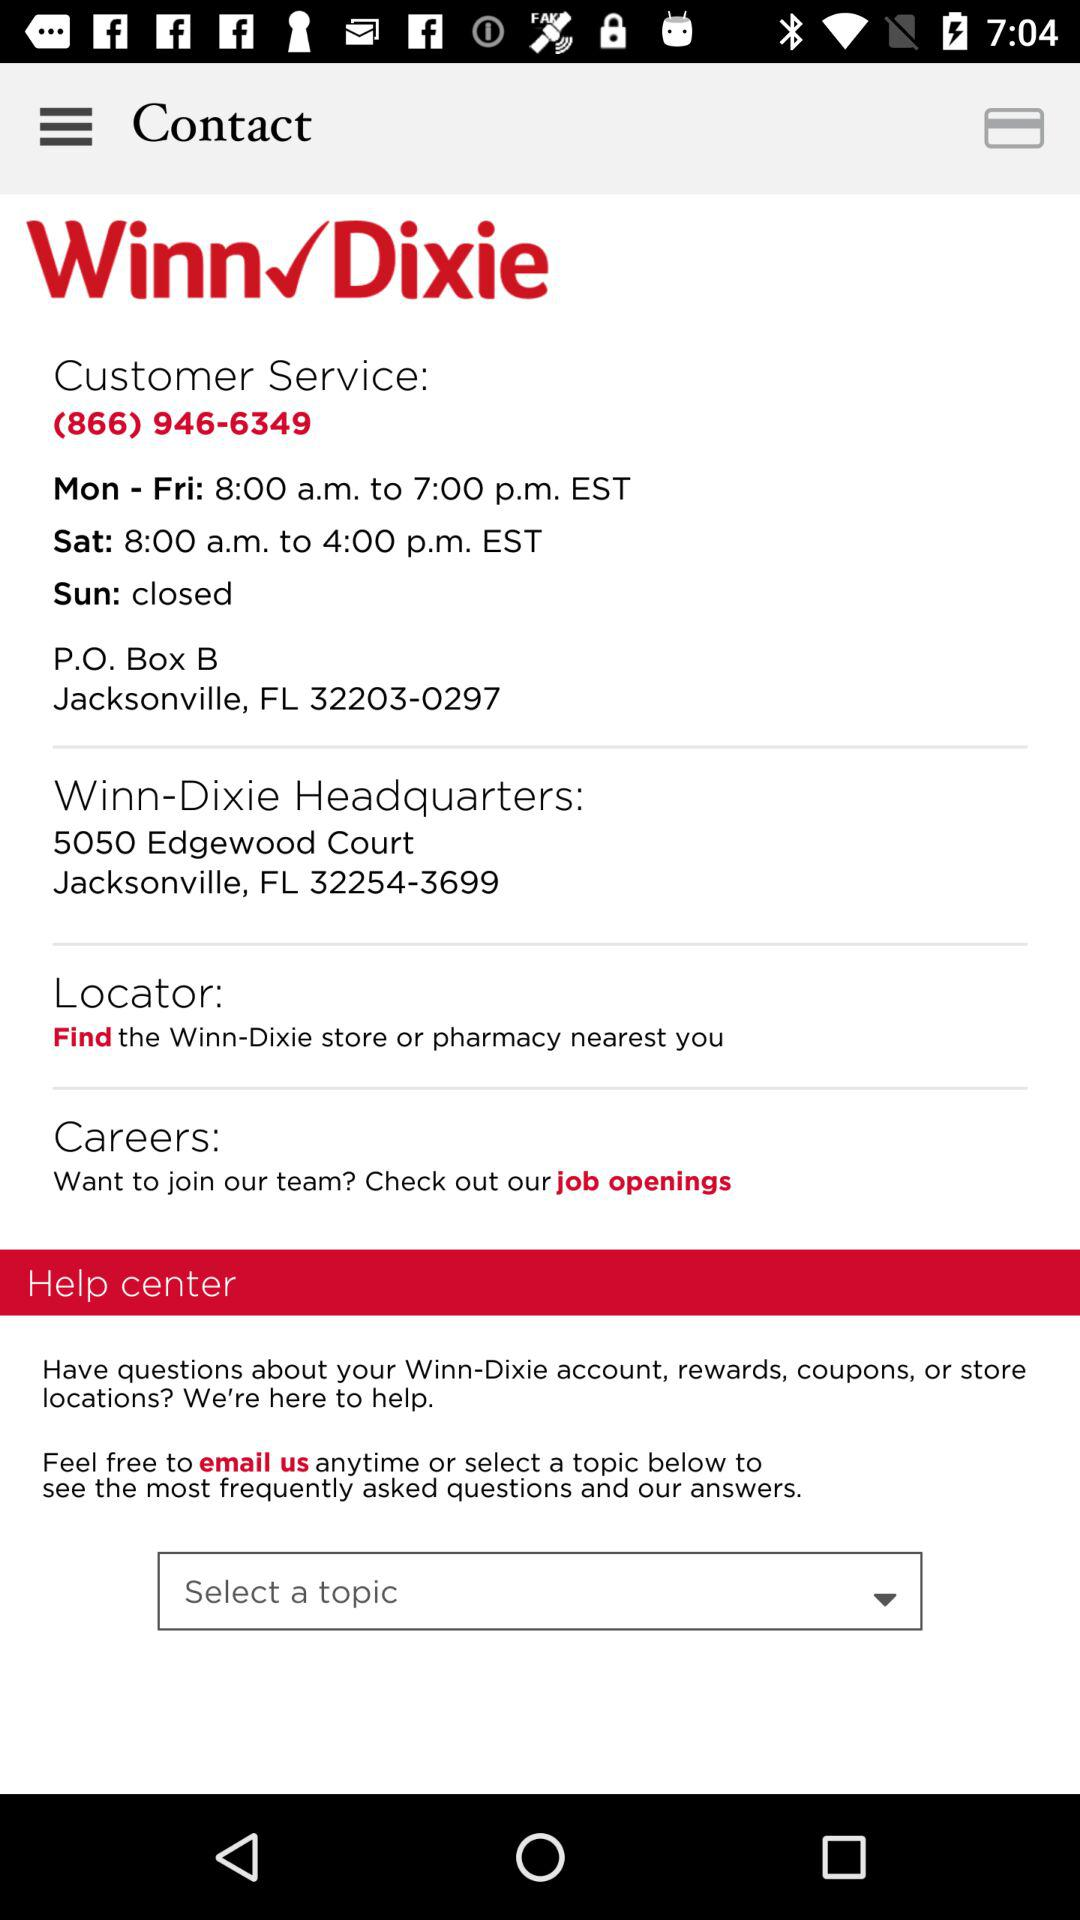How many contact options are there?
Answer the question using a single word or phrase. 3 